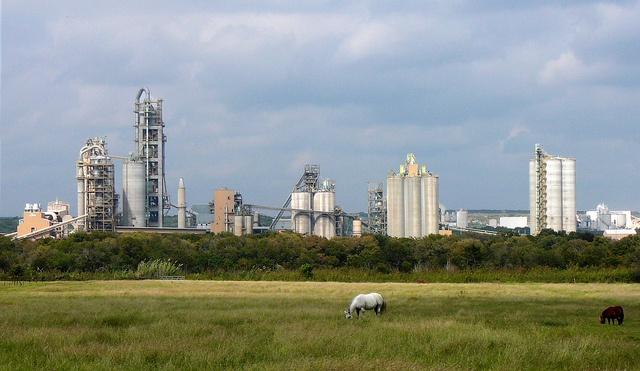Describe the objects in this image and their specific colors. I can see horse in lavender, darkgray, black, lightgray, and gray tones and horse in lavender, black, maroon, and darkgreen tones in this image. 